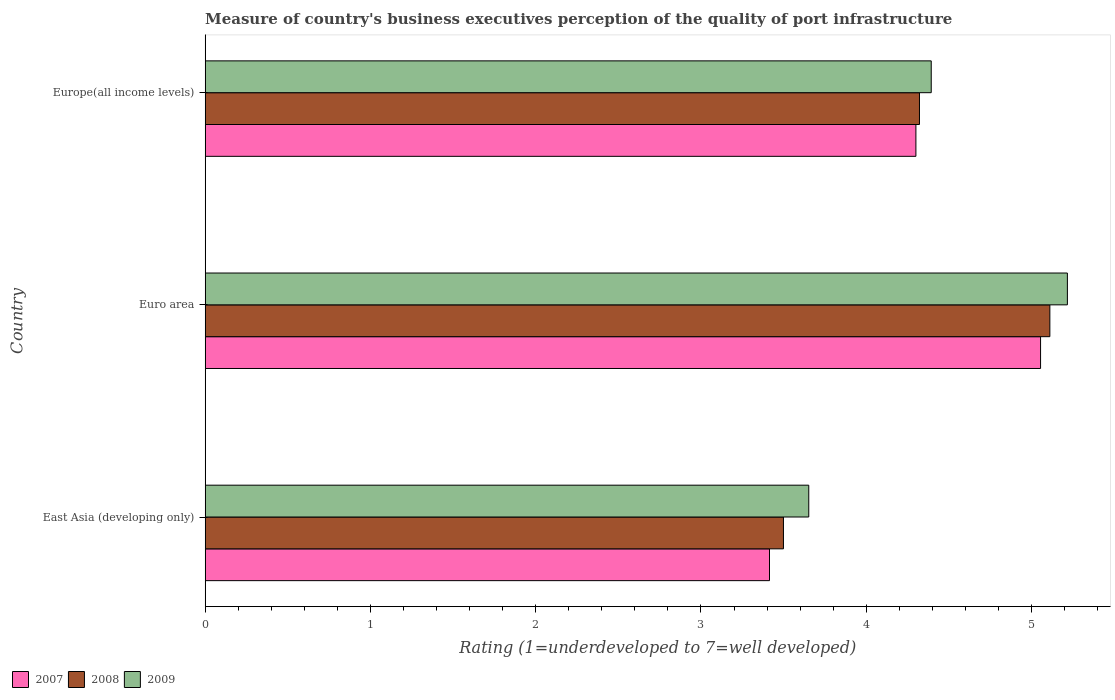Are the number of bars per tick equal to the number of legend labels?
Your answer should be very brief. Yes. Are the number of bars on each tick of the Y-axis equal?
Provide a short and direct response. Yes. How many bars are there on the 1st tick from the top?
Keep it short and to the point. 3. How many bars are there on the 1st tick from the bottom?
Your answer should be compact. 3. What is the label of the 1st group of bars from the top?
Provide a short and direct response. Europe(all income levels). What is the ratings of the quality of port infrastructure in 2008 in Euro area?
Ensure brevity in your answer.  5.11. Across all countries, what is the maximum ratings of the quality of port infrastructure in 2008?
Your answer should be compact. 5.11. Across all countries, what is the minimum ratings of the quality of port infrastructure in 2009?
Keep it short and to the point. 3.65. In which country was the ratings of the quality of port infrastructure in 2009 maximum?
Your answer should be very brief. Euro area. In which country was the ratings of the quality of port infrastructure in 2008 minimum?
Provide a succinct answer. East Asia (developing only). What is the total ratings of the quality of port infrastructure in 2007 in the graph?
Your answer should be very brief. 12.77. What is the difference between the ratings of the quality of port infrastructure in 2008 in East Asia (developing only) and that in Europe(all income levels)?
Ensure brevity in your answer.  -0.82. What is the difference between the ratings of the quality of port infrastructure in 2008 in Euro area and the ratings of the quality of port infrastructure in 2009 in East Asia (developing only)?
Offer a terse response. 1.46. What is the average ratings of the quality of port infrastructure in 2007 per country?
Your answer should be very brief. 4.26. What is the difference between the ratings of the quality of port infrastructure in 2007 and ratings of the quality of port infrastructure in 2008 in East Asia (developing only)?
Provide a short and direct response. -0.08. In how many countries, is the ratings of the quality of port infrastructure in 2007 greater than 4.8 ?
Keep it short and to the point. 1. What is the ratio of the ratings of the quality of port infrastructure in 2009 in East Asia (developing only) to that in Europe(all income levels)?
Your response must be concise. 0.83. What is the difference between the highest and the second highest ratings of the quality of port infrastructure in 2008?
Offer a very short reply. 0.79. What is the difference between the highest and the lowest ratings of the quality of port infrastructure in 2009?
Keep it short and to the point. 1.56. Is the sum of the ratings of the quality of port infrastructure in 2009 in Euro area and Europe(all income levels) greater than the maximum ratings of the quality of port infrastructure in 2008 across all countries?
Make the answer very short. Yes. What does the 3rd bar from the bottom in East Asia (developing only) represents?
Your answer should be very brief. 2009. How many bars are there?
Offer a terse response. 9. What is the difference between two consecutive major ticks on the X-axis?
Your answer should be very brief. 1. Are the values on the major ticks of X-axis written in scientific E-notation?
Your answer should be compact. No. Does the graph contain any zero values?
Ensure brevity in your answer.  No. How are the legend labels stacked?
Your response must be concise. Horizontal. What is the title of the graph?
Provide a succinct answer. Measure of country's business executives perception of the quality of port infrastructure. Does "1966" appear as one of the legend labels in the graph?
Offer a very short reply. No. What is the label or title of the X-axis?
Give a very brief answer. Rating (1=underdeveloped to 7=well developed). What is the label or title of the Y-axis?
Provide a succinct answer. Country. What is the Rating (1=underdeveloped to 7=well developed) of 2007 in East Asia (developing only)?
Provide a short and direct response. 3.41. What is the Rating (1=underdeveloped to 7=well developed) in 2008 in East Asia (developing only)?
Your answer should be very brief. 3.5. What is the Rating (1=underdeveloped to 7=well developed) of 2009 in East Asia (developing only)?
Make the answer very short. 3.65. What is the Rating (1=underdeveloped to 7=well developed) in 2007 in Euro area?
Provide a succinct answer. 5.05. What is the Rating (1=underdeveloped to 7=well developed) of 2008 in Euro area?
Give a very brief answer. 5.11. What is the Rating (1=underdeveloped to 7=well developed) in 2009 in Euro area?
Offer a very short reply. 5.22. What is the Rating (1=underdeveloped to 7=well developed) in 2007 in Europe(all income levels)?
Ensure brevity in your answer.  4.3. What is the Rating (1=underdeveloped to 7=well developed) in 2008 in Europe(all income levels)?
Ensure brevity in your answer.  4.32. What is the Rating (1=underdeveloped to 7=well developed) of 2009 in Europe(all income levels)?
Make the answer very short. 4.39. Across all countries, what is the maximum Rating (1=underdeveloped to 7=well developed) of 2007?
Your response must be concise. 5.05. Across all countries, what is the maximum Rating (1=underdeveloped to 7=well developed) in 2008?
Provide a short and direct response. 5.11. Across all countries, what is the maximum Rating (1=underdeveloped to 7=well developed) in 2009?
Provide a succinct answer. 5.22. Across all countries, what is the minimum Rating (1=underdeveloped to 7=well developed) of 2007?
Offer a terse response. 3.41. Across all countries, what is the minimum Rating (1=underdeveloped to 7=well developed) of 2008?
Offer a terse response. 3.5. Across all countries, what is the minimum Rating (1=underdeveloped to 7=well developed) in 2009?
Your response must be concise. 3.65. What is the total Rating (1=underdeveloped to 7=well developed) of 2007 in the graph?
Provide a succinct answer. 12.77. What is the total Rating (1=underdeveloped to 7=well developed) in 2008 in the graph?
Your answer should be compact. 12.93. What is the total Rating (1=underdeveloped to 7=well developed) of 2009 in the graph?
Your answer should be very brief. 13.26. What is the difference between the Rating (1=underdeveloped to 7=well developed) in 2007 in East Asia (developing only) and that in Euro area?
Your answer should be compact. -1.64. What is the difference between the Rating (1=underdeveloped to 7=well developed) in 2008 in East Asia (developing only) and that in Euro area?
Provide a short and direct response. -1.61. What is the difference between the Rating (1=underdeveloped to 7=well developed) of 2009 in East Asia (developing only) and that in Euro area?
Provide a short and direct response. -1.56. What is the difference between the Rating (1=underdeveloped to 7=well developed) in 2007 in East Asia (developing only) and that in Europe(all income levels)?
Ensure brevity in your answer.  -0.89. What is the difference between the Rating (1=underdeveloped to 7=well developed) in 2008 in East Asia (developing only) and that in Europe(all income levels)?
Provide a succinct answer. -0.82. What is the difference between the Rating (1=underdeveloped to 7=well developed) in 2009 in East Asia (developing only) and that in Europe(all income levels)?
Keep it short and to the point. -0.74. What is the difference between the Rating (1=underdeveloped to 7=well developed) of 2007 in Euro area and that in Europe(all income levels)?
Ensure brevity in your answer.  0.75. What is the difference between the Rating (1=underdeveloped to 7=well developed) of 2008 in Euro area and that in Europe(all income levels)?
Ensure brevity in your answer.  0.79. What is the difference between the Rating (1=underdeveloped to 7=well developed) in 2009 in Euro area and that in Europe(all income levels)?
Keep it short and to the point. 0.82. What is the difference between the Rating (1=underdeveloped to 7=well developed) in 2007 in East Asia (developing only) and the Rating (1=underdeveloped to 7=well developed) in 2008 in Euro area?
Your answer should be compact. -1.7. What is the difference between the Rating (1=underdeveloped to 7=well developed) in 2007 in East Asia (developing only) and the Rating (1=underdeveloped to 7=well developed) in 2009 in Euro area?
Your answer should be compact. -1.8. What is the difference between the Rating (1=underdeveloped to 7=well developed) in 2008 in East Asia (developing only) and the Rating (1=underdeveloped to 7=well developed) in 2009 in Euro area?
Keep it short and to the point. -1.72. What is the difference between the Rating (1=underdeveloped to 7=well developed) of 2007 in East Asia (developing only) and the Rating (1=underdeveloped to 7=well developed) of 2008 in Europe(all income levels)?
Give a very brief answer. -0.91. What is the difference between the Rating (1=underdeveloped to 7=well developed) of 2007 in East Asia (developing only) and the Rating (1=underdeveloped to 7=well developed) of 2009 in Europe(all income levels)?
Give a very brief answer. -0.98. What is the difference between the Rating (1=underdeveloped to 7=well developed) in 2008 in East Asia (developing only) and the Rating (1=underdeveloped to 7=well developed) in 2009 in Europe(all income levels)?
Provide a succinct answer. -0.89. What is the difference between the Rating (1=underdeveloped to 7=well developed) of 2007 in Euro area and the Rating (1=underdeveloped to 7=well developed) of 2008 in Europe(all income levels)?
Give a very brief answer. 0.73. What is the difference between the Rating (1=underdeveloped to 7=well developed) of 2007 in Euro area and the Rating (1=underdeveloped to 7=well developed) of 2009 in Europe(all income levels)?
Your answer should be compact. 0.66. What is the difference between the Rating (1=underdeveloped to 7=well developed) of 2008 in Euro area and the Rating (1=underdeveloped to 7=well developed) of 2009 in Europe(all income levels)?
Your response must be concise. 0.72. What is the average Rating (1=underdeveloped to 7=well developed) in 2007 per country?
Your response must be concise. 4.26. What is the average Rating (1=underdeveloped to 7=well developed) of 2008 per country?
Keep it short and to the point. 4.31. What is the average Rating (1=underdeveloped to 7=well developed) in 2009 per country?
Your response must be concise. 4.42. What is the difference between the Rating (1=underdeveloped to 7=well developed) in 2007 and Rating (1=underdeveloped to 7=well developed) in 2008 in East Asia (developing only)?
Make the answer very short. -0.08. What is the difference between the Rating (1=underdeveloped to 7=well developed) of 2007 and Rating (1=underdeveloped to 7=well developed) of 2009 in East Asia (developing only)?
Give a very brief answer. -0.24. What is the difference between the Rating (1=underdeveloped to 7=well developed) of 2008 and Rating (1=underdeveloped to 7=well developed) of 2009 in East Asia (developing only)?
Keep it short and to the point. -0.15. What is the difference between the Rating (1=underdeveloped to 7=well developed) in 2007 and Rating (1=underdeveloped to 7=well developed) in 2008 in Euro area?
Your answer should be very brief. -0.06. What is the difference between the Rating (1=underdeveloped to 7=well developed) in 2007 and Rating (1=underdeveloped to 7=well developed) in 2009 in Euro area?
Your answer should be compact. -0.16. What is the difference between the Rating (1=underdeveloped to 7=well developed) in 2008 and Rating (1=underdeveloped to 7=well developed) in 2009 in Euro area?
Provide a short and direct response. -0.11. What is the difference between the Rating (1=underdeveloped to 7=well developed) in 2007 and Rating (1=underdeveloped to 7=well developed) in 2008 in Europe(all income levels)?
Ensure brevity in your answer.  -0.02. What is the difference between the Rating (1=underdeveloped to 7=well developed) in 2007 and Rating (1=underdeveloped to 7=well developed) in 2009 in Europe(all income levels)?
Ensure brevity in your answer.  -0.09. What is the difference between the Rating (1=underdeveloped to 7=well developed) in 2008 and Rating (1=underdeveloped to 7=well developed) in 2009 in Europe(all income levels)?
Your answer should be very brief. -0.07. What is the ratio of the Rating (1=underdeveloped to 7=well developed) of 2007 in East Asia (developing only) to that in Euro area?
Your answer should be very brief. 0.68. What is the ratio of the Rating (1=underdeveloped to 7=well developed) in 2008 in East Asia (developing only) to that in Euro area?
Your response must be concise. 0.68. What is the ratio of the Rating (1=underdeveloped to 7=well developed) of 2009 in East Asia (developing only) to that in Euro area?
Keep it short and to the point. 0.7. What is the ratio of the Rating (1=underdeveloped to 7=well developed) in 2007 in East Asia (developing only) to that in Europe(all income levels)?
Ensure brevity in your answer.  0.79. What is the ratio of the Rating (1=underdeveloped to 7=well developed) of 2008 in East Asia (developing only) to that in Europe(all income levels)?
Give a very brief answer. 0.81. What is the ratio of the Rating (1=underdeveloped to 7=well developed) in 2009 in East Asia (developing only) to that in Europe(all income levels)?
Your answer should be very brief. 0.83. What is the ratio of the Rating (1=underdeveloped to 7=well developed) in 2007 in Euro area to that in Europe(all income levels)?
Keep it short and to the point. 1.18. What is the ratio of the Rating (1=underdeveloped to 7=well developed) in 2008 in Euro area to that in Europe(all income levels)?
Your answer should be very brief. 1.18. What is the ratio of the Rating (1=underdeveloped to 7=well developed) of 2009 in Euro area to that in Europe(all income levels)?
Your response must be concise. 1.19. What is the difference between the highest and the second highest Rating (1=underdeveloped to 7=well developed) in 2007?
Ensure brevity in your answer.  0.75. What is the difference between the highest and the second highest Rating (1=underdeveloped to 7=well developed) of 2008?
Provide a short and direct response. 0.79. What is the difference between the highest and the second highest Rating (1=underdeveloped to 7=well developed) in 2009?
Provide a short and direct response. 0.82. What is the difference between the highest and the lowest Rating (1=underdeveloped to 7=well developed) in 2007?
Offer a terse response. 1.64. What is the difference between the highest and the lowest Rating (1=underdeveloped to 7=well developed) of 2008?
Ensure brevity in your answer.  1.61. What is the difference between the highest and the lowest Rating (1=underdeveloped to 7=well developed) in 2009?
Your answer should be very brief. 1.56. 